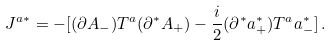Convert formula to latex. <formula><loc_0><loc_0><loc_500><loc_500>J ^ { a * } = - [ ( \partial A _ { - } ) T ^ { a } ( \partial ^ { * } A _ { + } ) - \frac { i } { 2 } ( \partial ^ { * } a _ { + } ^ { * } ) T ^ { a } a _ { - } ^ { * } ] \, .</formula> 